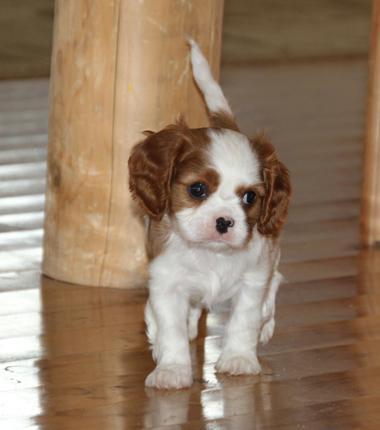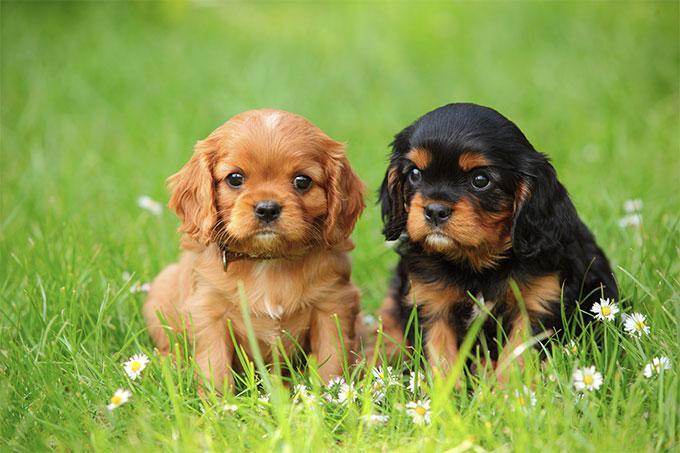The first image is the image on the left, the second image is the image on the right. For the images displayed, is the sentence "There are more dogs in the right-hand image than the left." factually correct? Answer yes or no. Yes. 